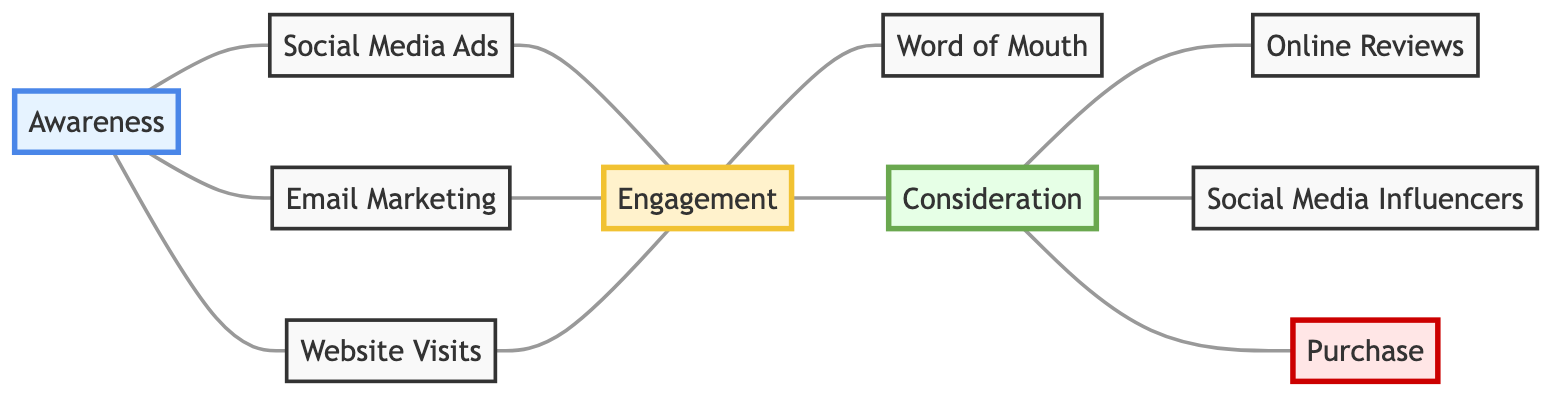What are the total number of nodes in the diagram? By counting the entries in the "nodes" array, we have a total of 10 distinct nodes representing different stages of the customer journey.
Answer: 10 Which nodes have a direct connection to "Awareness"? The nodes that are directly connected to "Awareness" (node 1) as per the edges are: "Social Media Ads", "Email Marketing", and "Website Visits".
Answer: Social Media Ads, Email Marketing, Website Visits What is the label of node 10? Referring to the "nodes" array, the label of node 10 is "Purchase", indicating the final step in the customer journey.
Answer: Purchase How many types of marketing channels are involved before "Consideration"? There are three channels involved directly before "Consideration": "Social Media Ads", "Email Marketing", and "Website Visits", which leads to "Engagement" before reaching "Consideration".
Answer: 3 What follows the "Engagement" stage in the customer journey? From the diagram flow, "Engagement" (node 5) leads to two stages: "Word of Mouth" and "Consideration".
Answer: Word of Mouth, Consideration Which node leads customers to "Online Reviews"? Customers move to "Online Reviews" (node 8) from "Consideration" (node 7) according to the edge connections of the diagram.
Answer: Consideration What is the relationship between "Consideration" and "Purchase"? According to the diagram, "Consideration" (node 7) directly connects to "Purchase" (node 10), indicating that after consideration, the customer proceeds to make a purchase.
Answer: Direct connection How many edges are connected to "Engagement"? By checking the edges connected to "Engagement" (node 5), we see there are three edges leading to "Word of Mouth", "Consideration", and back to itself. Thus, it has a total of 3 edges.
Answer: 3 